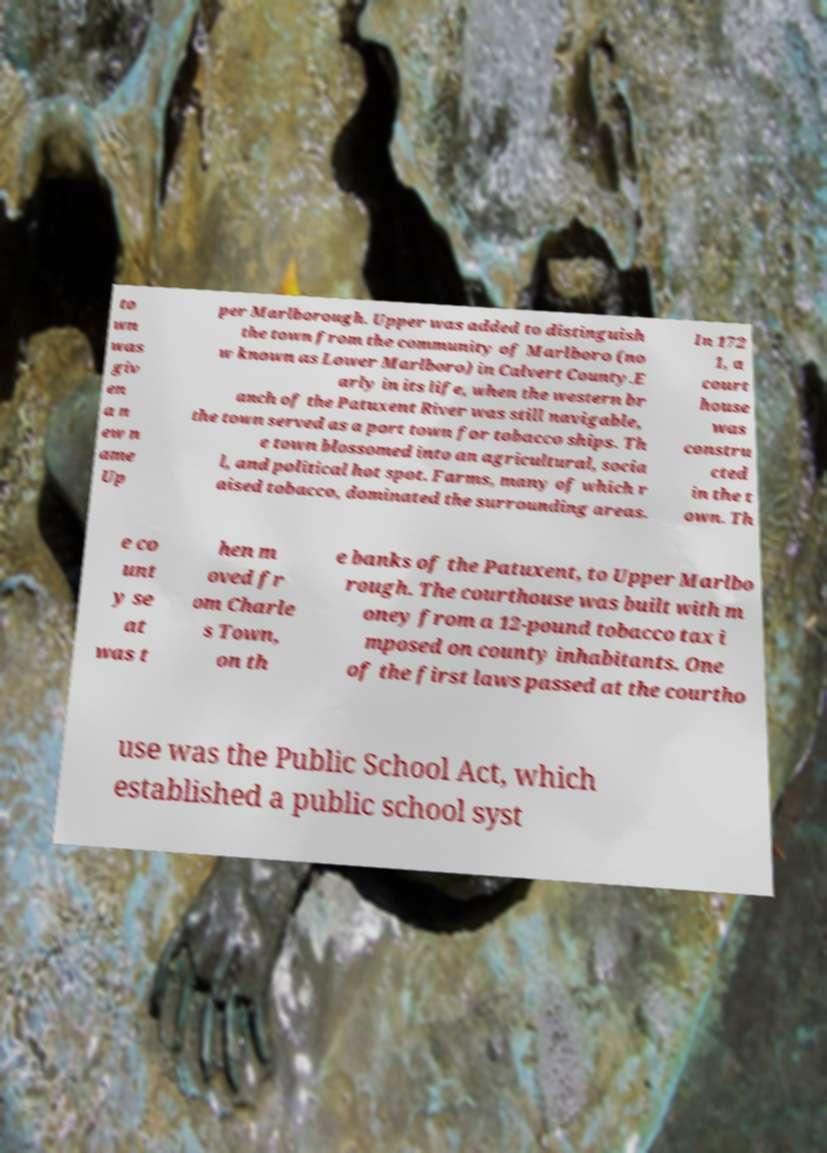Can you read and provide the text displayed in the image?This photo seems to have some interesting text. Can you extract and type it out for me? to wn was giv en a n ew n ame Up per Marlborough. Upper was added to distinguish the town from the community of Marlboro (no w known as Lower Marlboro) in Calvert County.E arly in its life, when the western br anch of the Patuxent River was still navigable, the town served as a port town for tobacco ships. Th e town blossomed into an agricultural, socia l, and political hot spot. Farms, many of which r aised tobacco, dominated the surrounding areas. In 172 1, a court house was constru cted in the t own. Th e co unt y se at was t hen m oved fr om Charle s Town, on th e banks of the Patuxent, to Upper Marlbo rough. The courthouse was built with m oney from a 12-pound tobacco tax i mposed on county inhabitants. One of the first laws passed at the courtho use was the Public School Act, which established a public school syst 